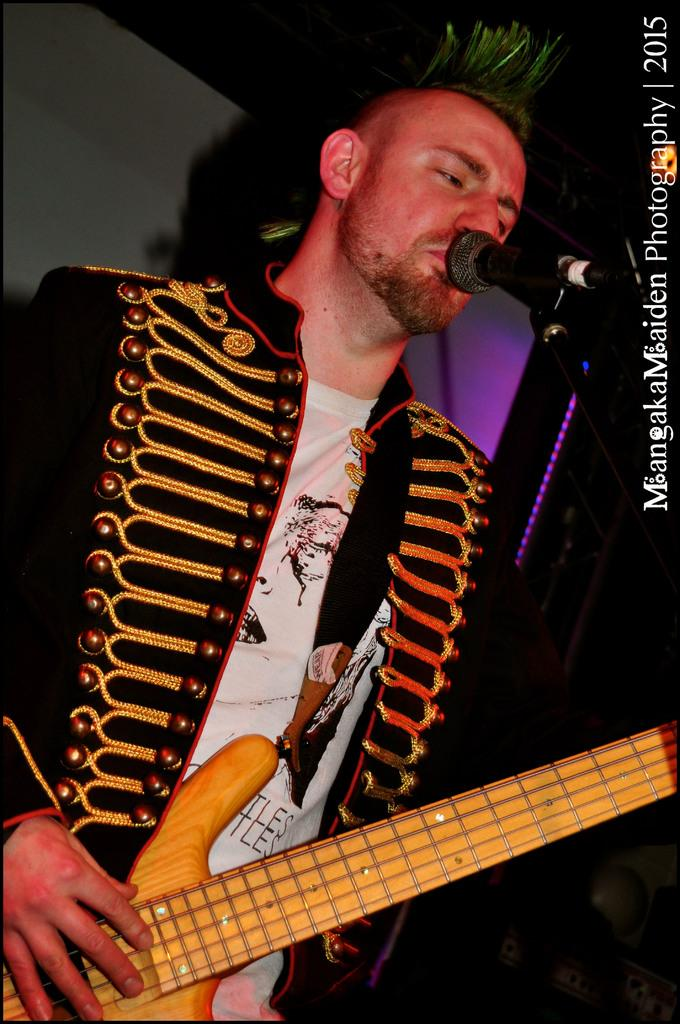What is the man in the image doing? The man in the image is singing and playing a guitar. What instrument is the man playing? The man is playing a guitar. What object is the man holding while singing? The man is holding a microphone. What is the man wearing? The man is wearing a black jacket. What is special about the black jacket? The black jacket has embroidery work on it. What type of wood is the rake made of in the image? There is no rake present in the image. How does the basketball contribute to the man's performance in the image? There is no basketball present in the image. 